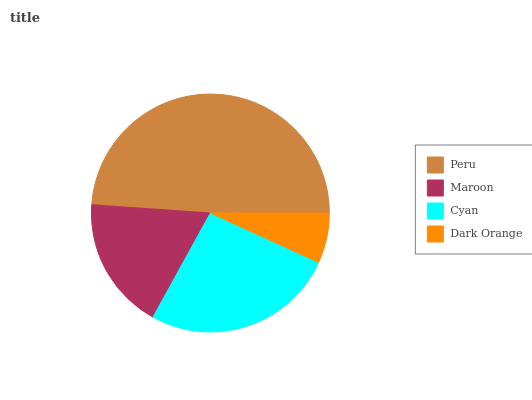Is Dark Orange the minimum?
Answer yes or no. Yes. Is Peru the maximum?
Answer yes or no. Yes. Is Maroon the minimum?
Answer yes or no. No. Is Maroon the maximum?
Answer yes or no. No. Is Peru greater than Maroon?
Answer yes or no. Yes. Is Maroon less than Peru?
Answer yes or no. Yes. Is Maroon greater than Peru?
Answer yes or no. No. Is Peru less than Maroon?
Answer yes or no. No. Is Cyan the high median?
Answer yes or no. Yes. Is Maroon the low median?
Answer yes or no. Yes. Is Peru the high median?
Answer yes or no. No. Is Peru the low median?
Answer yes or no. No. 